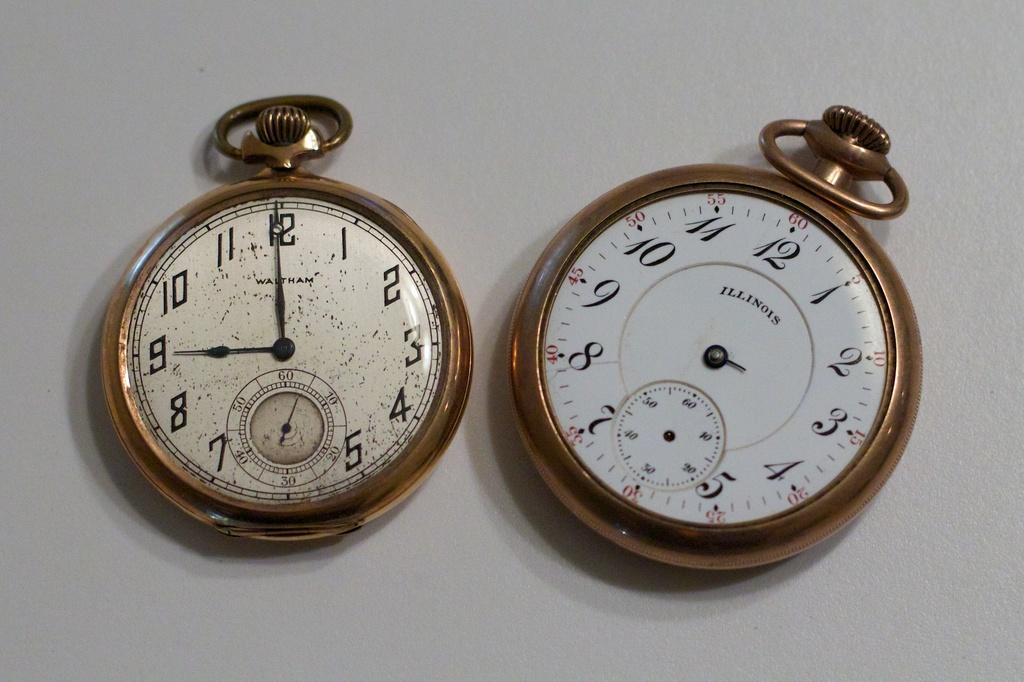<image>
Render a clear and concise summary of the photo. the number 12 that is on tha watch 